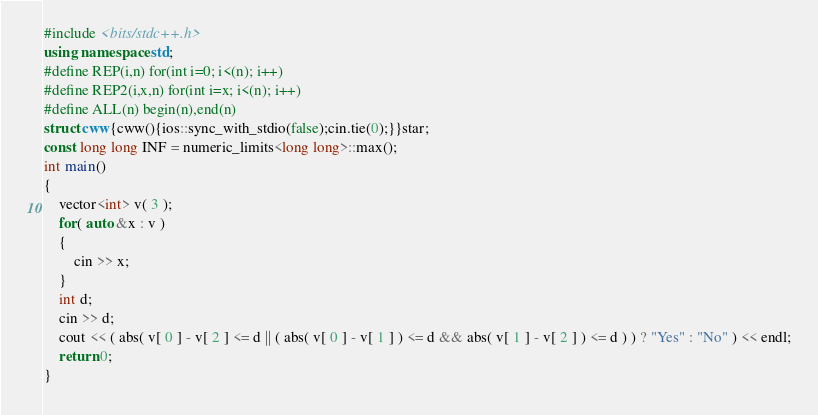Convert code to text. <code><loc_0><loc_0><loc_500><loc_500><_C++_>#include <bits/stdc++.h>
using namespace std;
#define REP(i,n) for(int i=0; i<(n); i++)
#define REP2(i,x,n) for(int i=x; i<(n); i++)
#define ALL(n) begin(n),end(n)
struct cww{cww(){ios::sync_with_stdio(false);cin.tie(0);}}star;
const long long INF = numeric_limits<long long>::max();
int main()
{
    vector<int> v( 3 );
    for( auto &x : v )
    {
        cin >> x;
    }
    int d;
    cin >> d;
    cout << ( abs( v[ 0 ] - v[ 2 ] <= d || ( abs( v[ 0 ] - v[ 1 ] ) <= d && abs( v[ 1 ] - v[ 2 ] ) <= d ) ) ? "Yes" : "No" ) << endl;
    return 0;
}</code> 